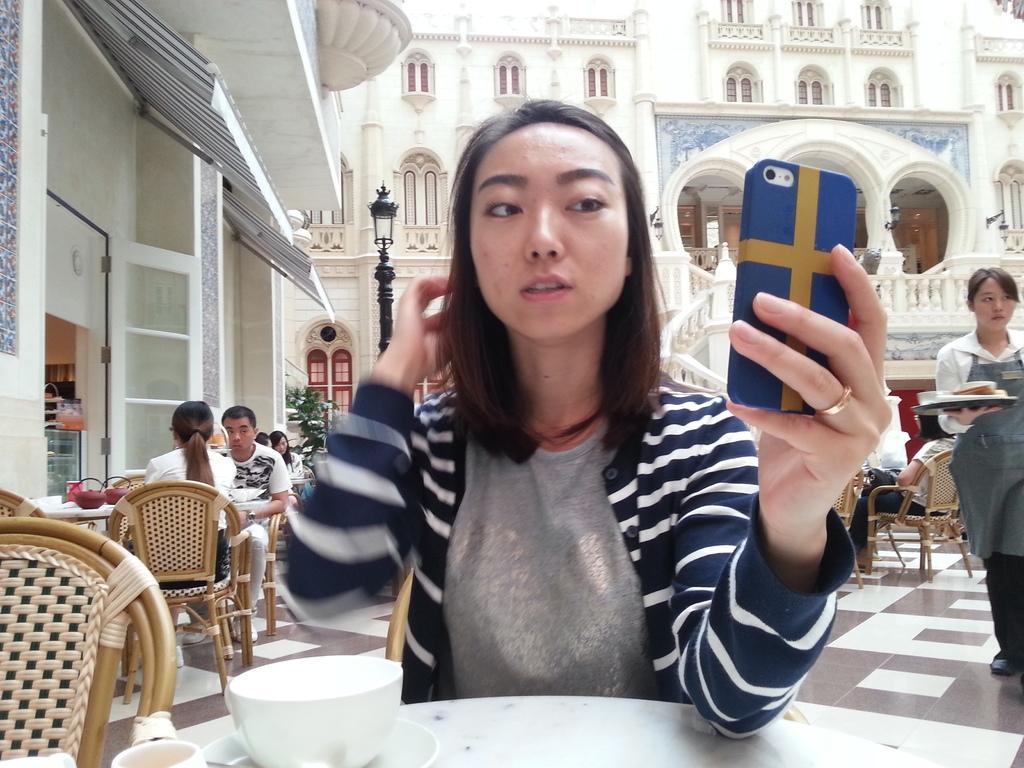Could you give a brief overview of what you see in this image? Here is a woman sitting and holding her mobile phone. This is a table with cup and saucer placed on it. At background I can see people sitting on the chairs. This is street light. At the right corner of the image I can see woman holding a tray and walking. This is a building with windows and it has a beautiful architecture. 